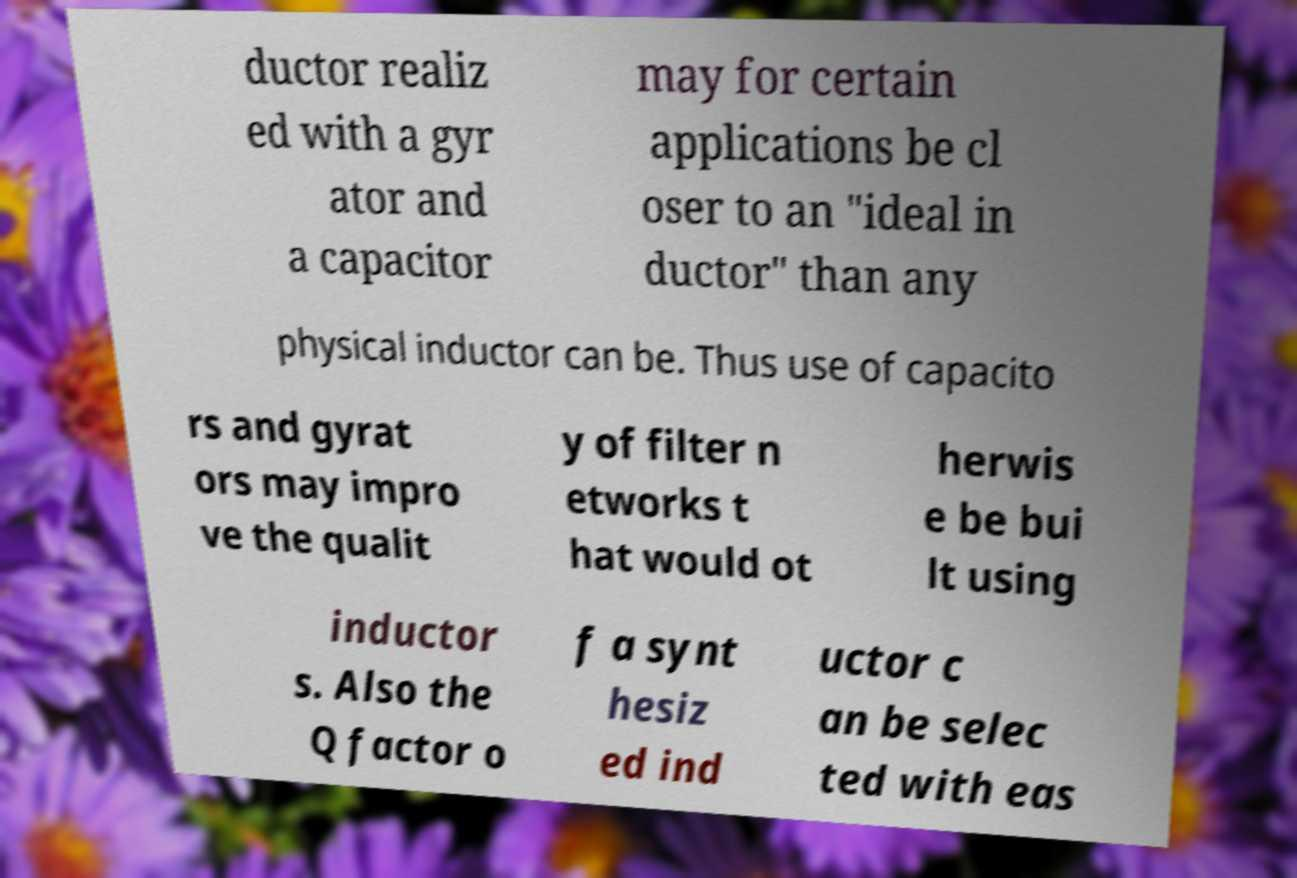Could you extract and type out the text from this image? ductor realiz ed with a gyr ator and a capacitor may for certain applications be cl oser to an "ideal in ductor" than any physical inductor can be. Thus use of capacito rs and gyrat ors may impro ve the qualit y of filter n etworks t hat would ot herwis e be bui lt using inductor s. Also the Q factor o f a synt hesiz ed ind uctor c an be selec ted with eas 